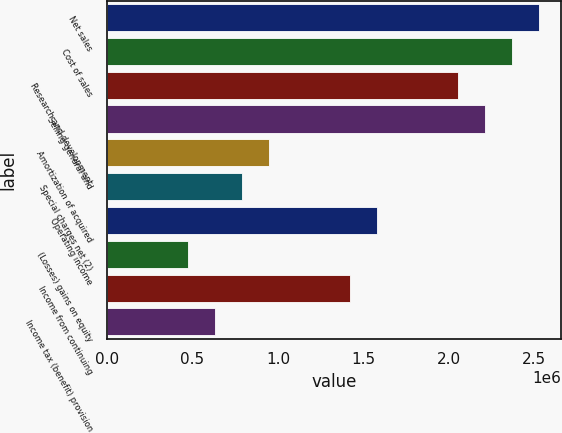<chart> <loc_0><loc_0><loc_500><loc_500><bar_chart><fcel>Net sales<fcel>Cost of sales<fcel>Research and development<fcel>Selling general and<fcel>Amortization of acquired<fcel>Special charges net (2)<fcel>Operating income<fcel>(Losses) gains on equity<fcel>Income from continuing<fcel>Income tax (benefit) provision<nl><fcel>2.5306e+06<fcel>2.37243e+06<fcel>2.05611e+06<fcel>2.21427e+06<fcel>948974<fcel>790812<fcel>1.58162e+06<fcel>474487<fcel>1.42346e+06<fcel>632650<nl></chart> 